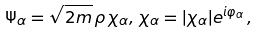Convert formula to latex. <formula><loc_0><loc_0><loc_500><loc_500>\Psi _ { \alpha } = \sqrt { 2 m } \, \rho \, \chi _ { \alpha } , \, \chi _ { \alpha } = | \chi _ { \alpha } | e ^ { i \varphi _ { \alpha } } \, ,</formula> 